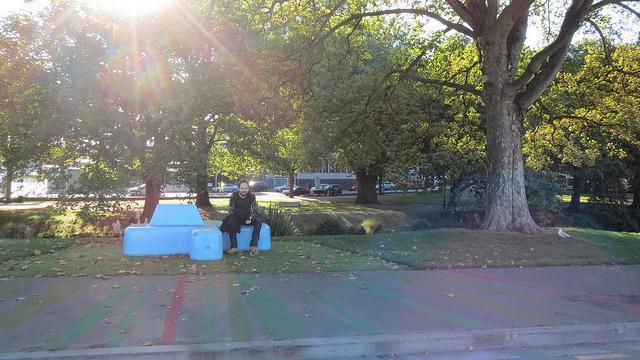How many sheep are there?
Give a very brief answer. 0. 